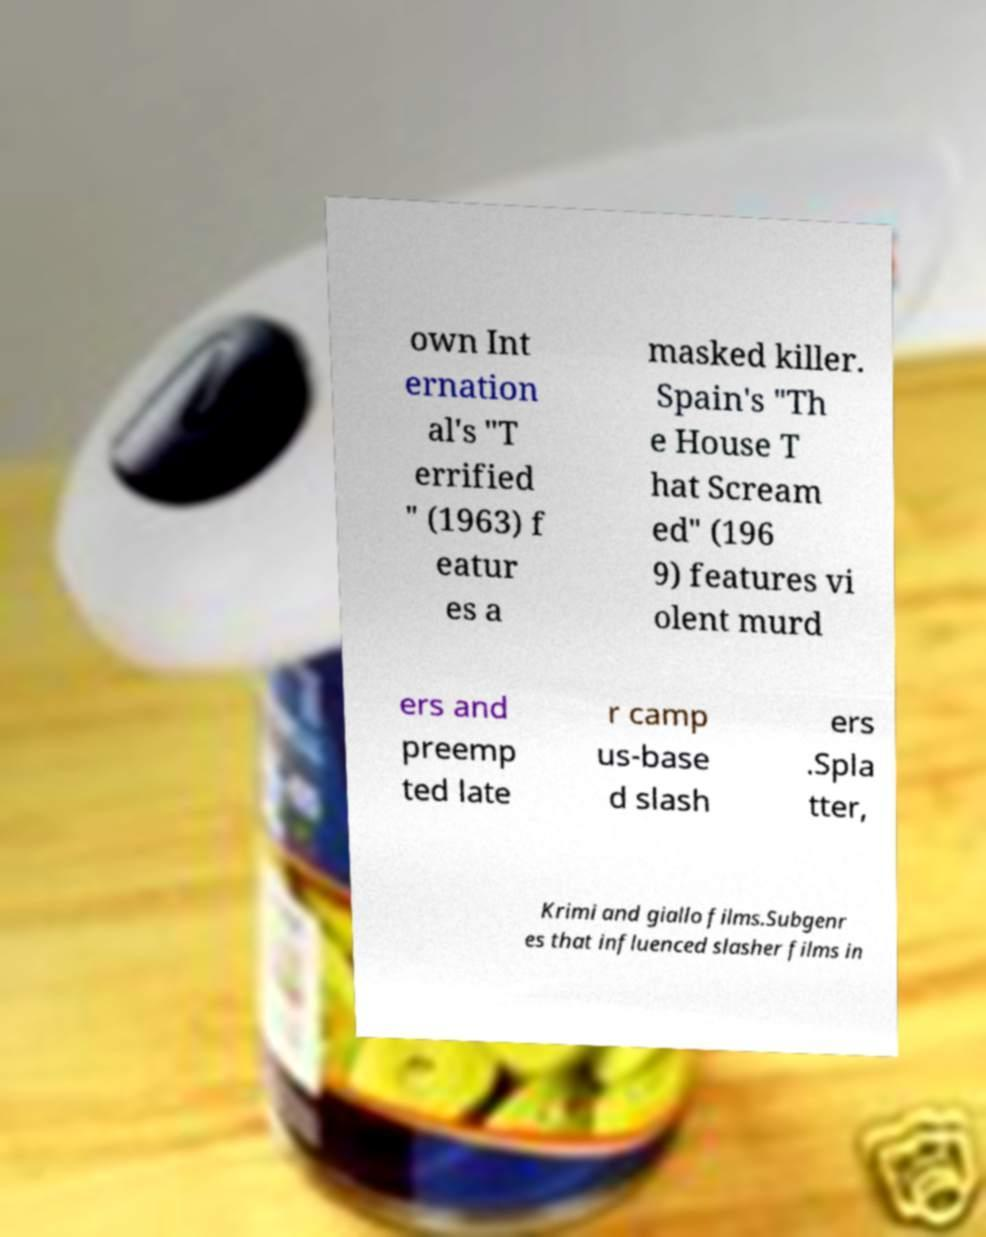Can you accurately transcribe the text from the provided image for me? own Int ernation al's "T errified " (1963) f eatur es a masked killer. Spain's "Th e House T hat Scream ed" (196 9) features vi olent murd ers and preemp ted late r camp us-base d slash ers .Spla tter, Krimi and giallo films.Subgenr es that influenced slasher films in 